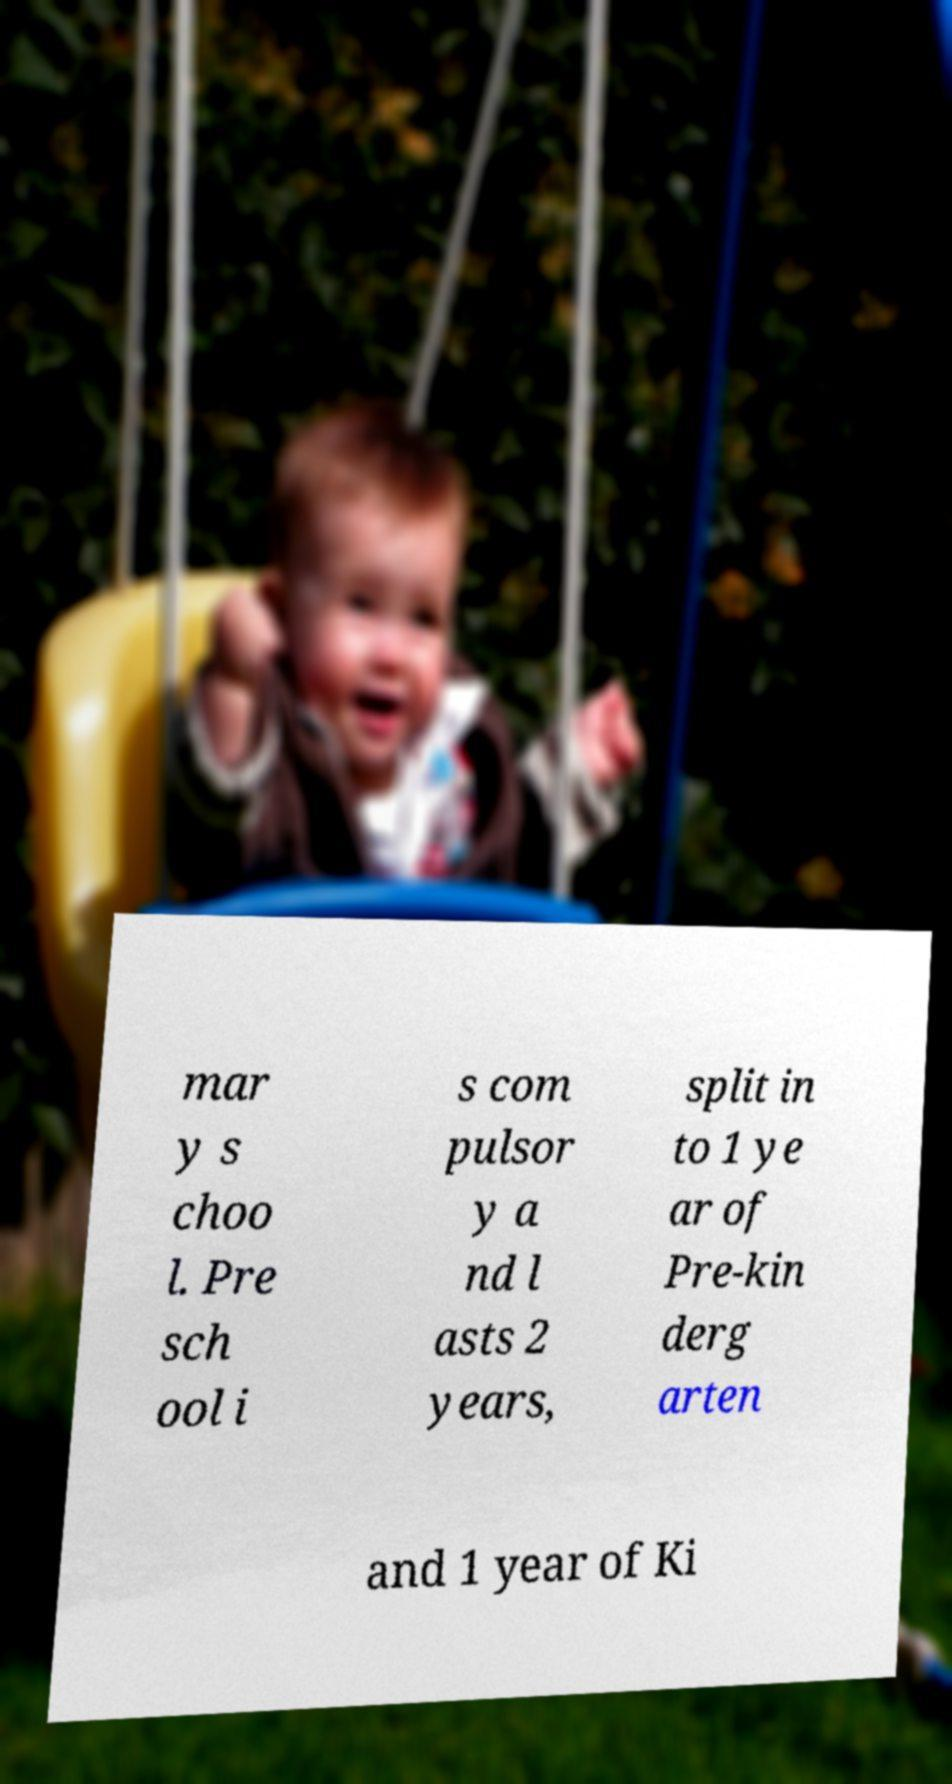Can you read and provide the text displayed in the image?This photo seems to have some interesting text. Can you extract and type it out for me? mar y s choo l. Pre sch ool i s com pulsor y a nd l asts 2 years, split in to 1 ye ar of Pre-kin derg arten and 1 year of Ki 